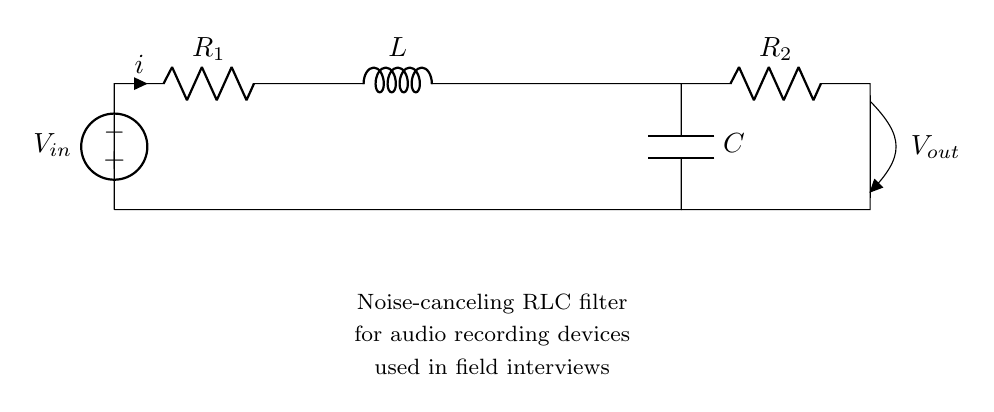What are the components in this circuit? The circuit diagram consists of a resistor, an inductor, and a capacitor. These elements are represented as R, L, and C respectively.
Answer: Resistor, Inductor, Capacitor What is the input voltage source labeled as? The input voltage source in the circuit is labeled as V in, which represents the voltage supplied to the circuit from the source.
Answer: V in How is the output voltage referred to in the circuit? The output voltage in the circuit is denoted as V out, indicating the voltage across the output terminals connected to R2.
Answer: V out Which component is placed first in the current path? The first component in the current path, as per the connections, is the resistor R1, which the current flows through before reaching the inductor.
Answer: R1 What is the role of the inductor in this configuration? The inductor L in this configuration contributes to filtering by opposing changes in current, which helps to cancel out certain noise frequencies.
Answer: Filtering noise How does the arrangement of R, L, and C affect the overall frequency response? The parallel arrangement of components results in a combination that can be tuned to specific frequencies, allowing the circuit to inhibit or enhance certain audio frequencies, which aids in noise cancellation.
Answer: Frequency tuning What is the benefit of using this noise-canceling RLC filter in field interviews? Using this noise-canceling RLC filter helps to improve audio quality by reducing unwanted noise, ensuring clearer recordings during field interviews.
Answer: Improved audio quality 